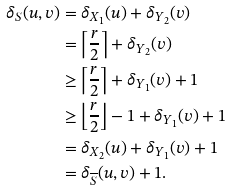Convert formula to latex. <formula><loc_0><loc_0><loc_500><loc_500>\delta _ { S } ( u , v ) & = \delta _ { X _ { 1 } } ( u ) + \delta _ { Y _ { 2 } } ( v ) \\ & = \left \lceil \frac { r } { 2 } \right \rceil + \delta _ { Y _ { 2 } } ( v ) \\ & \geq \left \lceil \frac { r } { 2 } \right \rceil + \delta _ { Y _ { 1 } } ( v ) + 1 \\ & \geq \left \lfloor \frac { r } { 2 } \right \rfloor - 1 + \delta _ { Y _ { 1 } } ( v ) + 1 \\ & = \delta _ { X _ { 2 } } ( u ) + \delta _ { Y _ { 1 } } ( v ) + 1 \\ & = \delta _ { \overline { S } } ( u , v ) + 1 .</formula> 